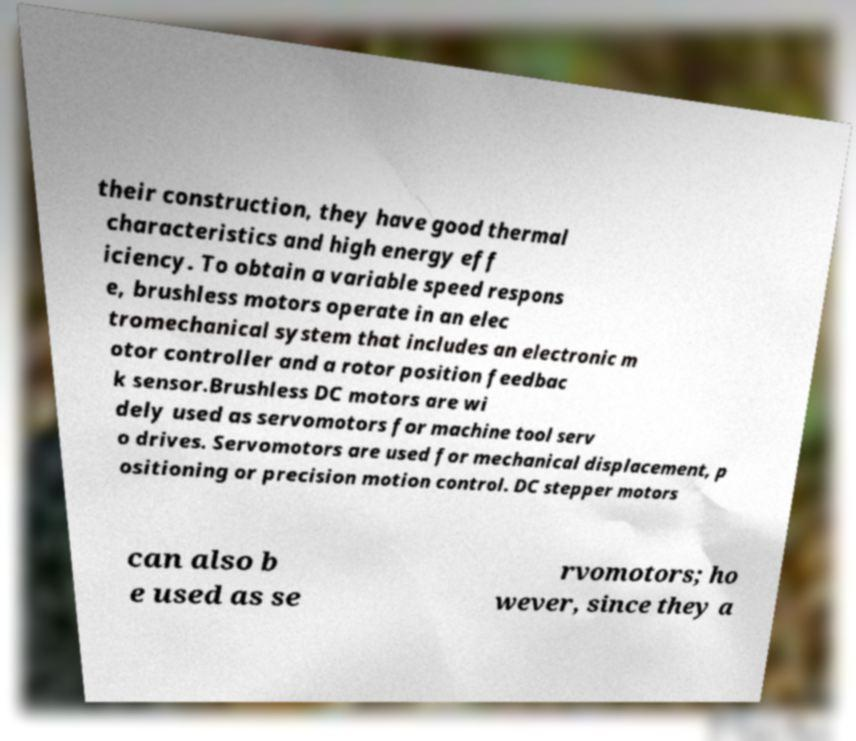Can you accurately transcribe the text from the provided image for me? their construction, they have good thermal characteristics and high energy eff iciency. To obtain a variable speed respons e, brushless motors operate in an elec tromechanical system that includes an electronic m otor controller and a rotor position feedbac k sensor.Brushless DC motors are wi dely used as servomotors for machine tool serv o drives. Servomotors are used for mechanical displacement, p ositioning or precision motion control. DC stepper motors can also b e used as se rvomotors; ho wever, since they a 